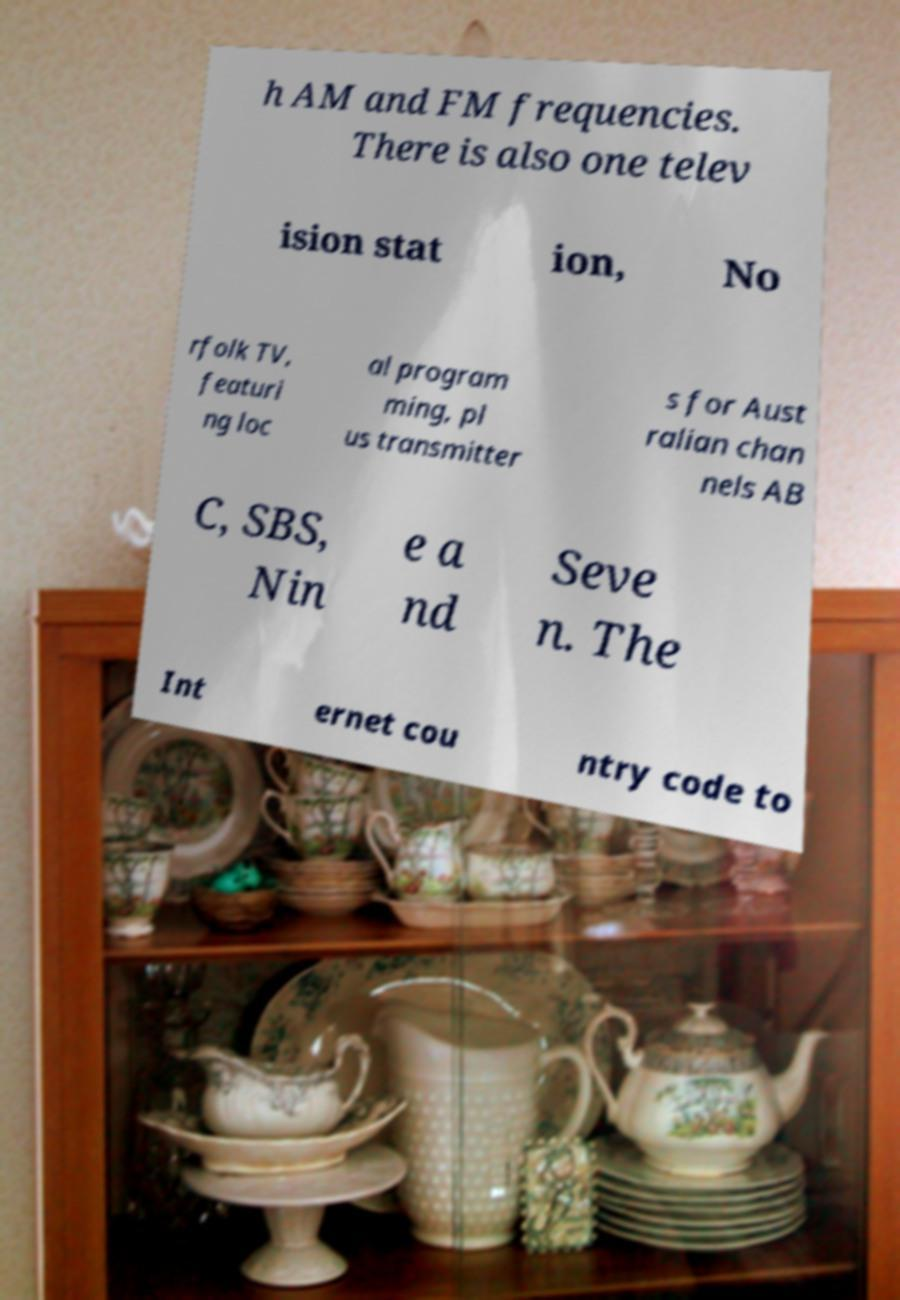For documentation purposes, I need the text within this image transcribed. Could you provide that? h AM and FM frequencies. There is also one telev ision stat ion, No rfolk TV, featuri ng loc al program ming, pl us transmitter s for Aust ralian chan nels AB C, SBS, Nin e a nd Seve n. The Int ernet cou ntry code to 